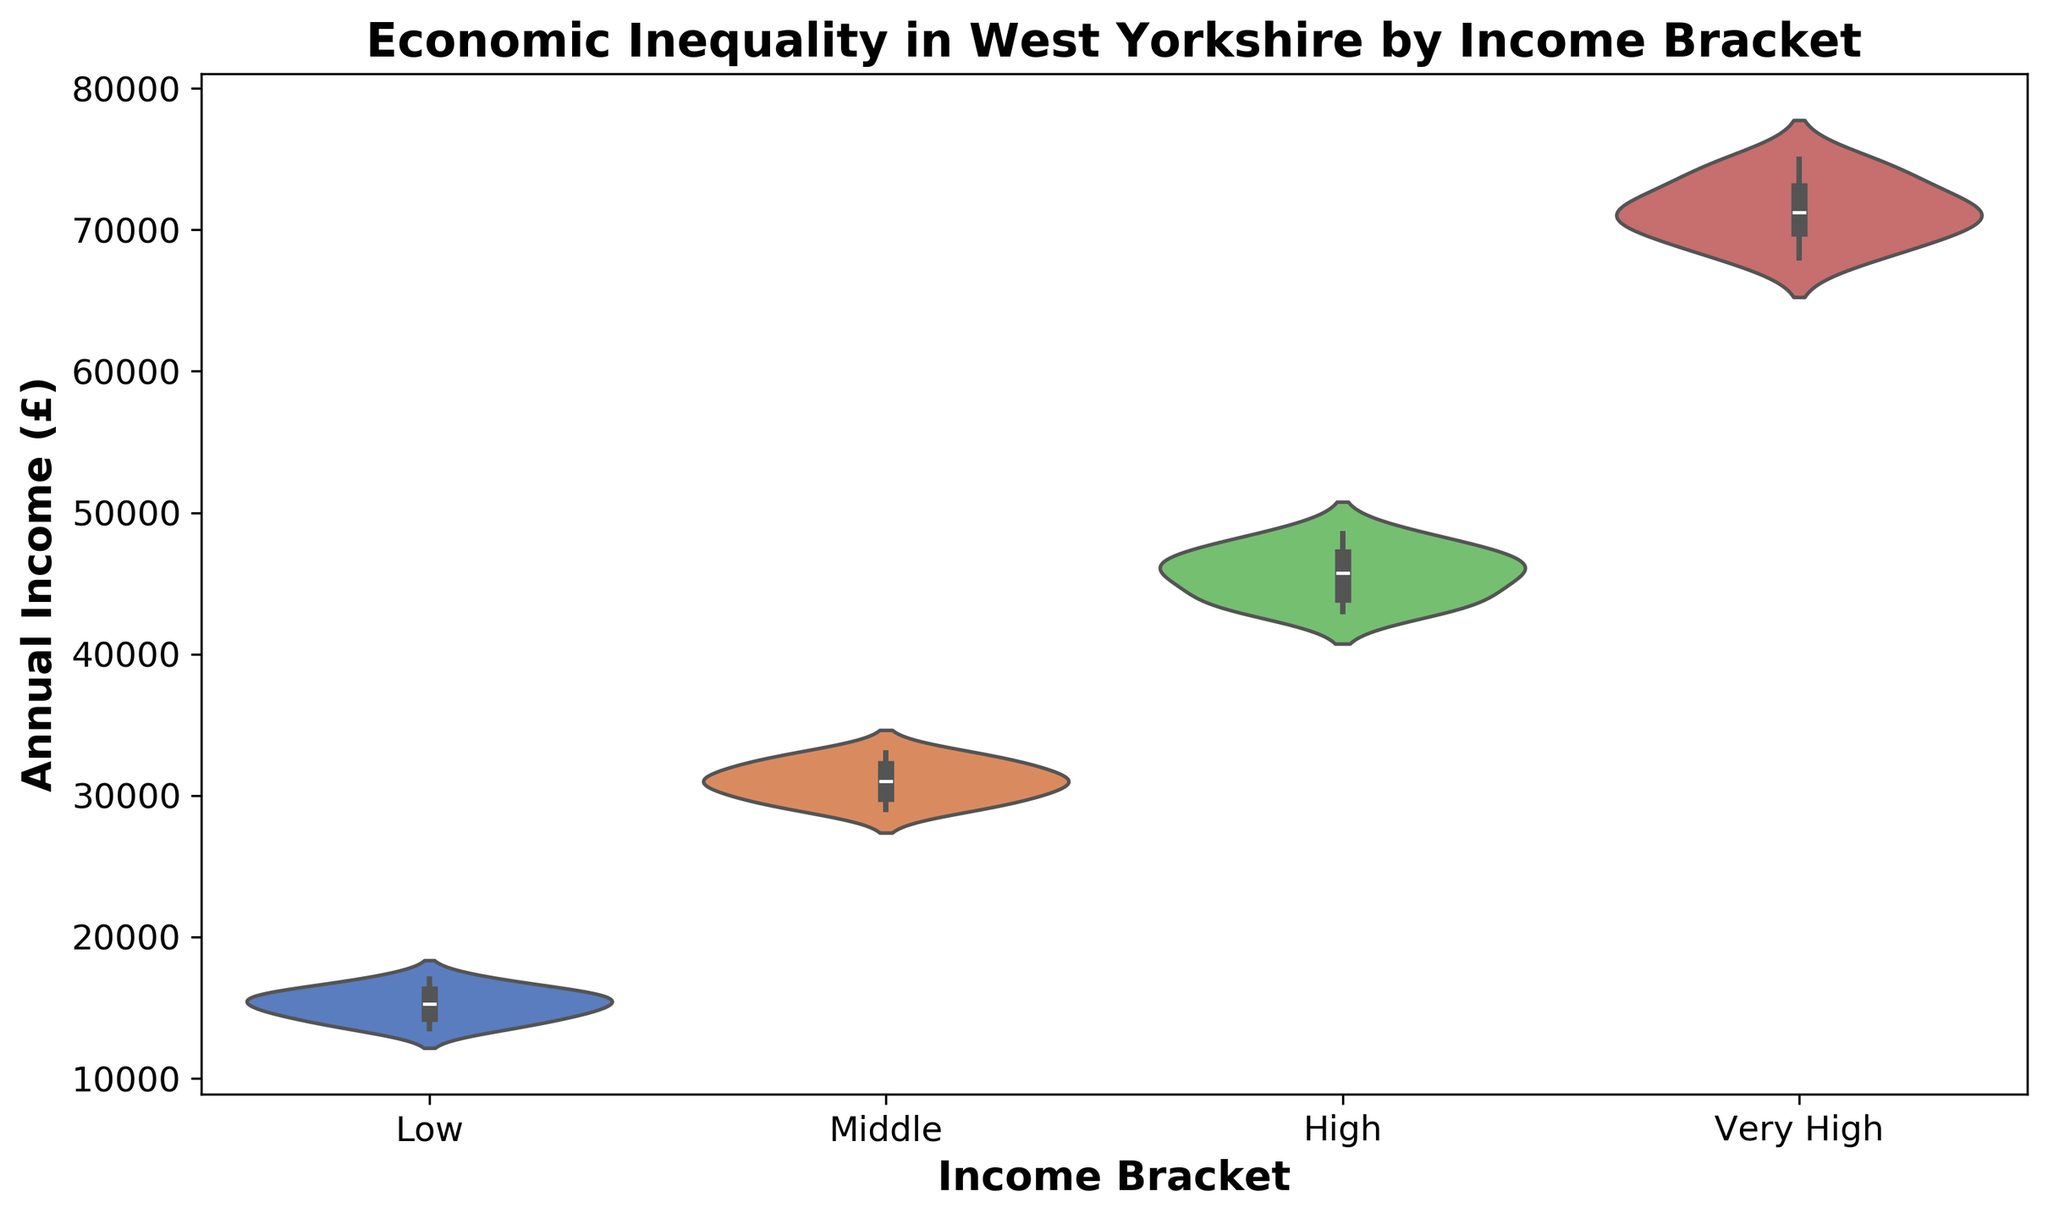what is the income range for the 'Very High' income bracket? The range can be determined by looking at the lower and upper edges of the 'Very High' violin plot. The lowest point seems to be around £68,000 and the highest point is approximately £75,000
Answer: £68,000 to £75,000 which income bracket has the widest range of annual incomes? This can be identified by visually comparing the vertical spread of each violin plot. The 'Very High' bracket has the greatest vertical spread, suggesting it has the widest range of annual incomes.
Answer: Very High what is the median income value for the 'Middle' income bracket? The median income value is the middle line within the 'Middle' income bracket’s violin plot. This can be visually approximated as around £31,000 as the line is closer to the actual middle.
Answer: £31,000 how does the median income value of 'Low' compare to that of 'High'? By identifying the middle line in both 'Low' and 'High' income brackets, we can compare the two values. The median of 'Low' seems to be around £15,500 while the median for 'High' is around £45,000.
Answer: 'Low' < 'High' what is the interquartile range (IQR) for the 'Low' income bracket? The IQR is the range within which the middle 50% of data points fall. This is roughly between £14,500 and £16,200 by visually identifying where the thickest part of the 'Low' violin plot lies.
Answer: £14,500 to £16,200 which income bracket has the highest median income value? The highest median income value is indicated by the highest middle line within the violin plots. The 'Very High' income bracket has the highest median.
Answer: Very High how are the individual values distributed in the 'High' income bracket? The distribution can be inferred by the shape of the violin plot. The 'High' income bracket appears to have a somewhat symmetric distribution with a denser concentration in the middle.
Answer: Symmetric, denser in the middle are the income values in the 'Middle' income bracket more concentrated towards the mean or spread out? By observing the shape of the 'Middle' violin plot, which shows a narrow waist, one can infer that incomes are more concentrated around the mean.
Answer: More concentrated around the mean how does the spread of income values in the 'Low' bracket compare to the 'Very High' bracket? By comparing the width of the two violin plots, the 'Very High' bracket is broader, displaying more variability in incomes, whereas the 'Low' bracket is narrower, indicating less variability.
Answer: 'Low' < 'Very High' what can be inferred about economic inequality from this figure? Visual inspection of the spread and distribution within each income bracket indicates that income inequality exists, particularly due to the broader spread in higher income brackets compared to lower ones.
Answer: Higher income inequality in higher brackets 